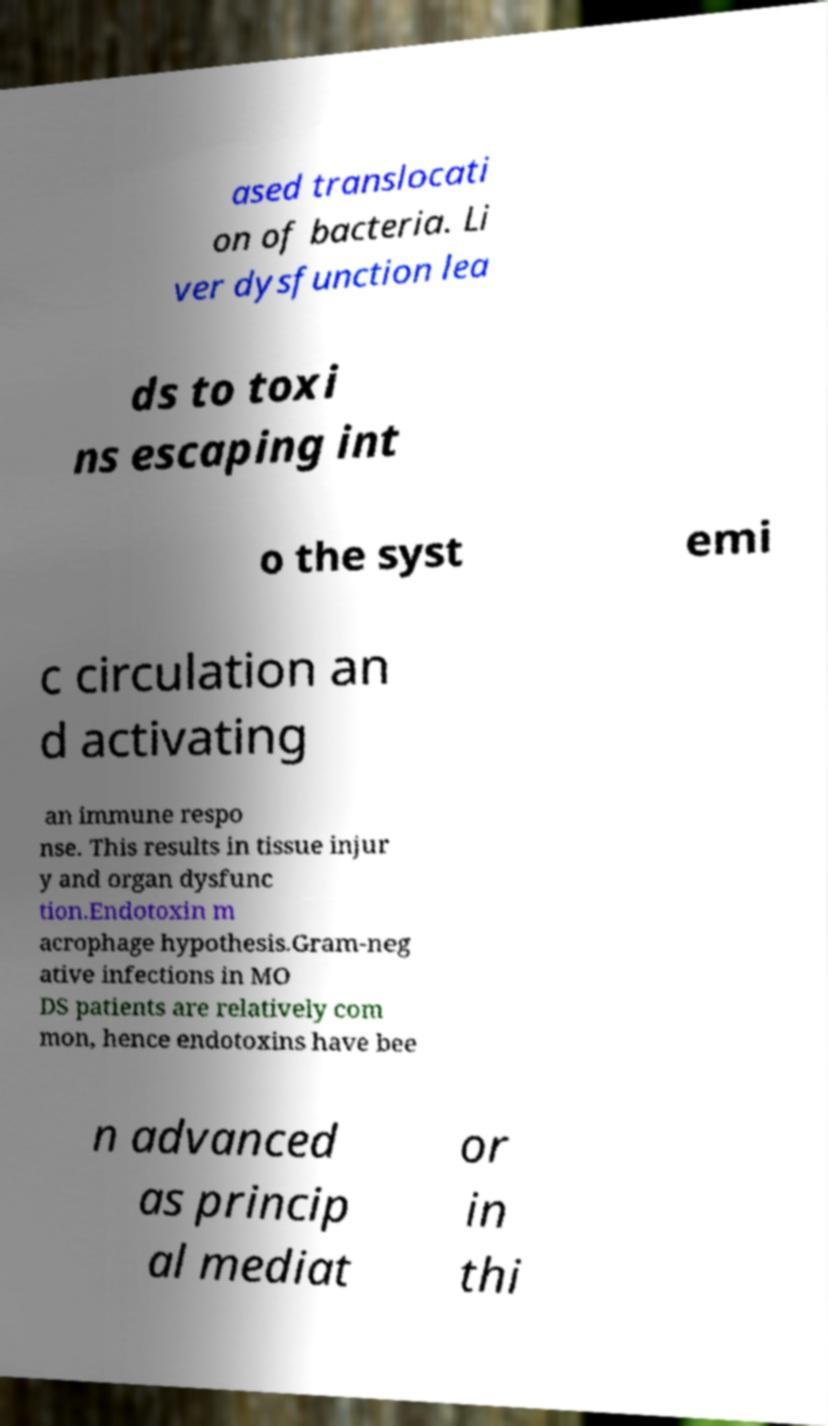Could you extract and type out the text from this image? ased translocati on of bacteria. Li ver dysfunction lea ds to toxi ns escaping int o the syst emi c circulation an d activating an immune respo nse. This results in tissue injur y and organ dysfunc tion.Endotoxin m acrophage hypothesis.Gram-neg ative infections in MO DS patients are relatively com mon, hence endotoxins have bee n advanced as princip al mediat or in thi 